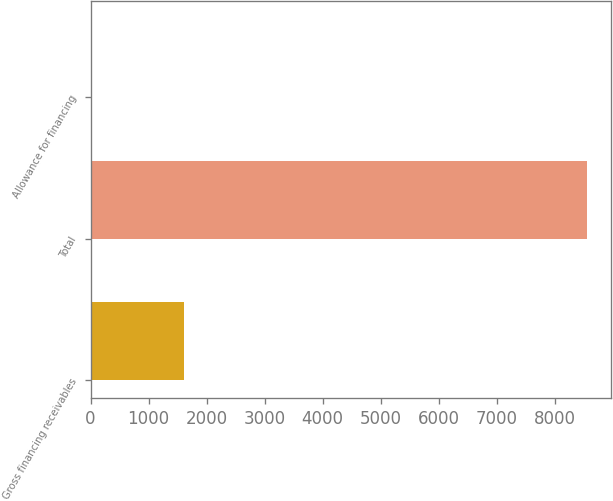Convert chart. <chart><loc_0><loc_0><loc_500><loc_500><bar_chart><fcel>Gross financing receivables<fcel>Total<fcel>Allowance for financing<nl><fcel>1619.4<fcel>8551.7<fcel>16<nl></chart> 